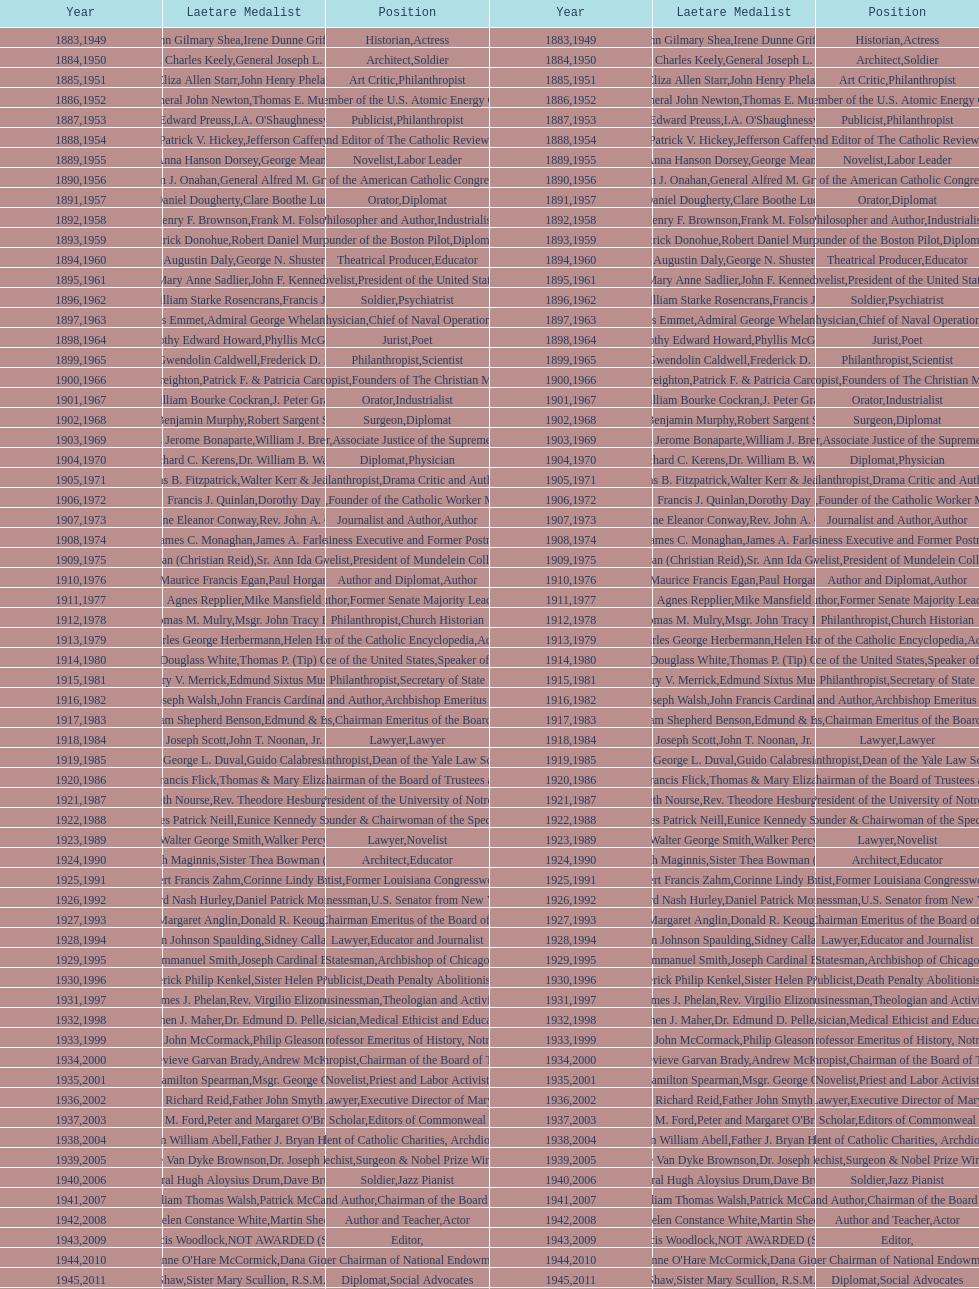How many lawyers have won the award between 1883 and 2014? 5. 